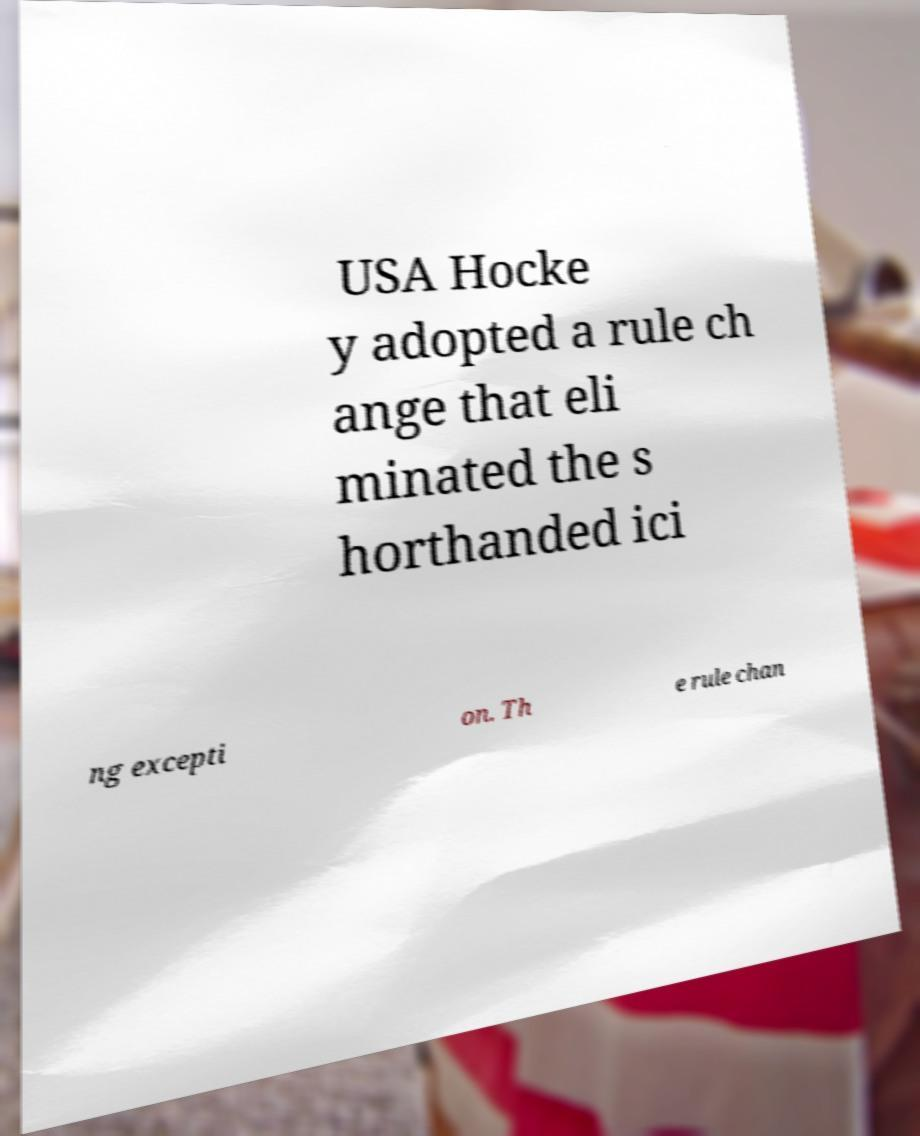For documentation purposes, I need the text within this image transcribed. Could you provide that? USA Hocke y adopted a rule ch ange that eli minated the s horthanded ici ng excepti on. Th e rule chan 